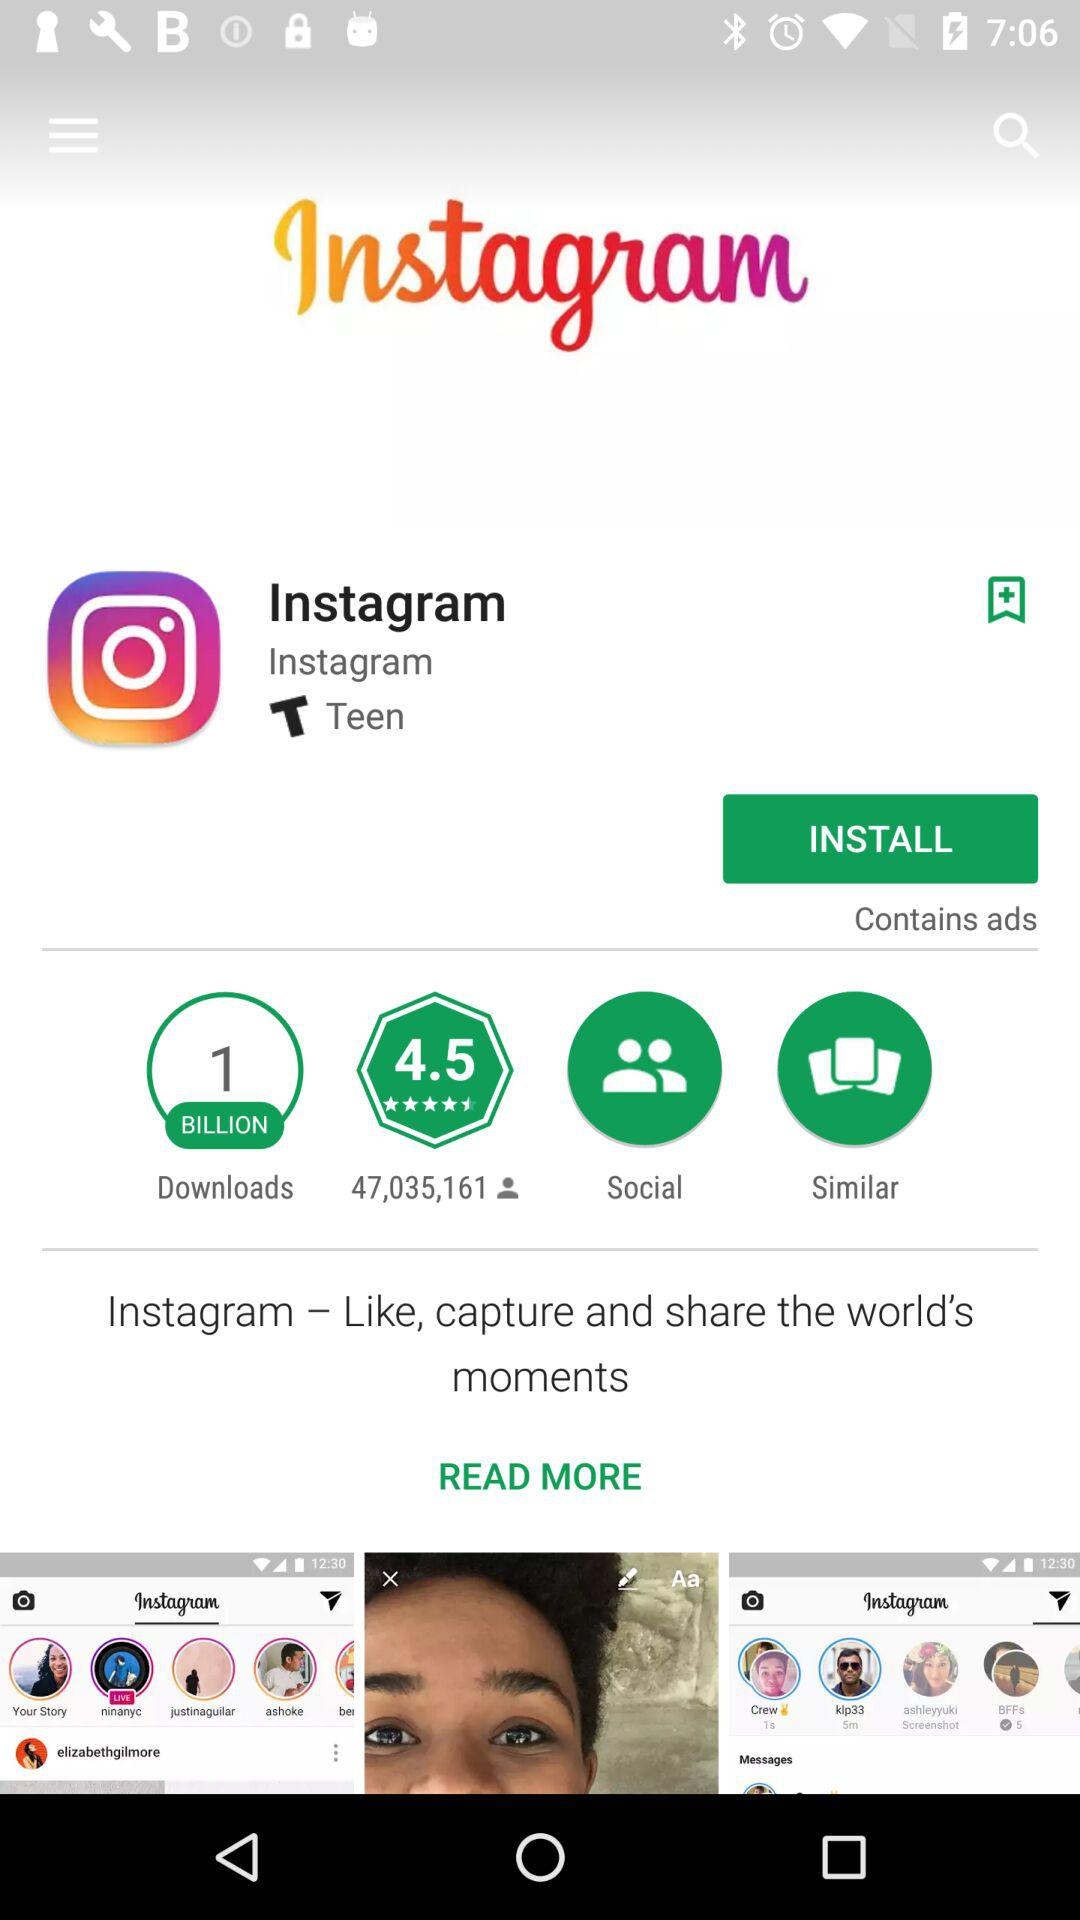What does the user rating say about the application's performance? The user rating of 4.5 stars indicates a very positive reception from users, suggesting that the app performs well and meets the needs and expectations of its users. 